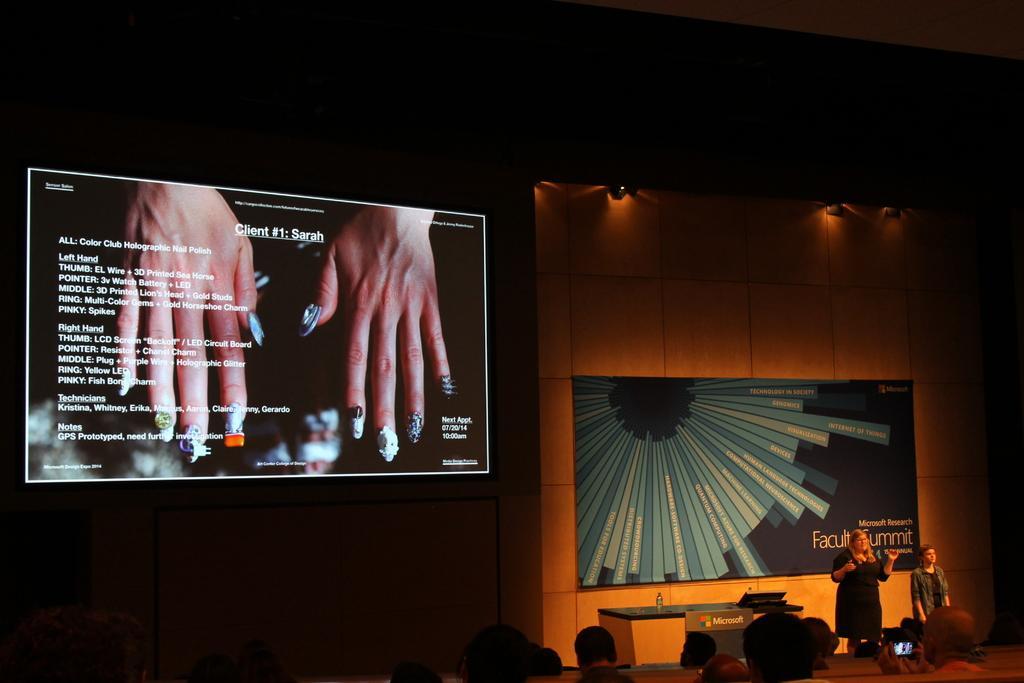Describe this image in one or two sentences. In this image i can see number of persons sitting and the person on the right corner is holding a camera, On the stage i can see a man and the woman standing. In the background i can see the wall, few lights, the poster and a huge screen. 